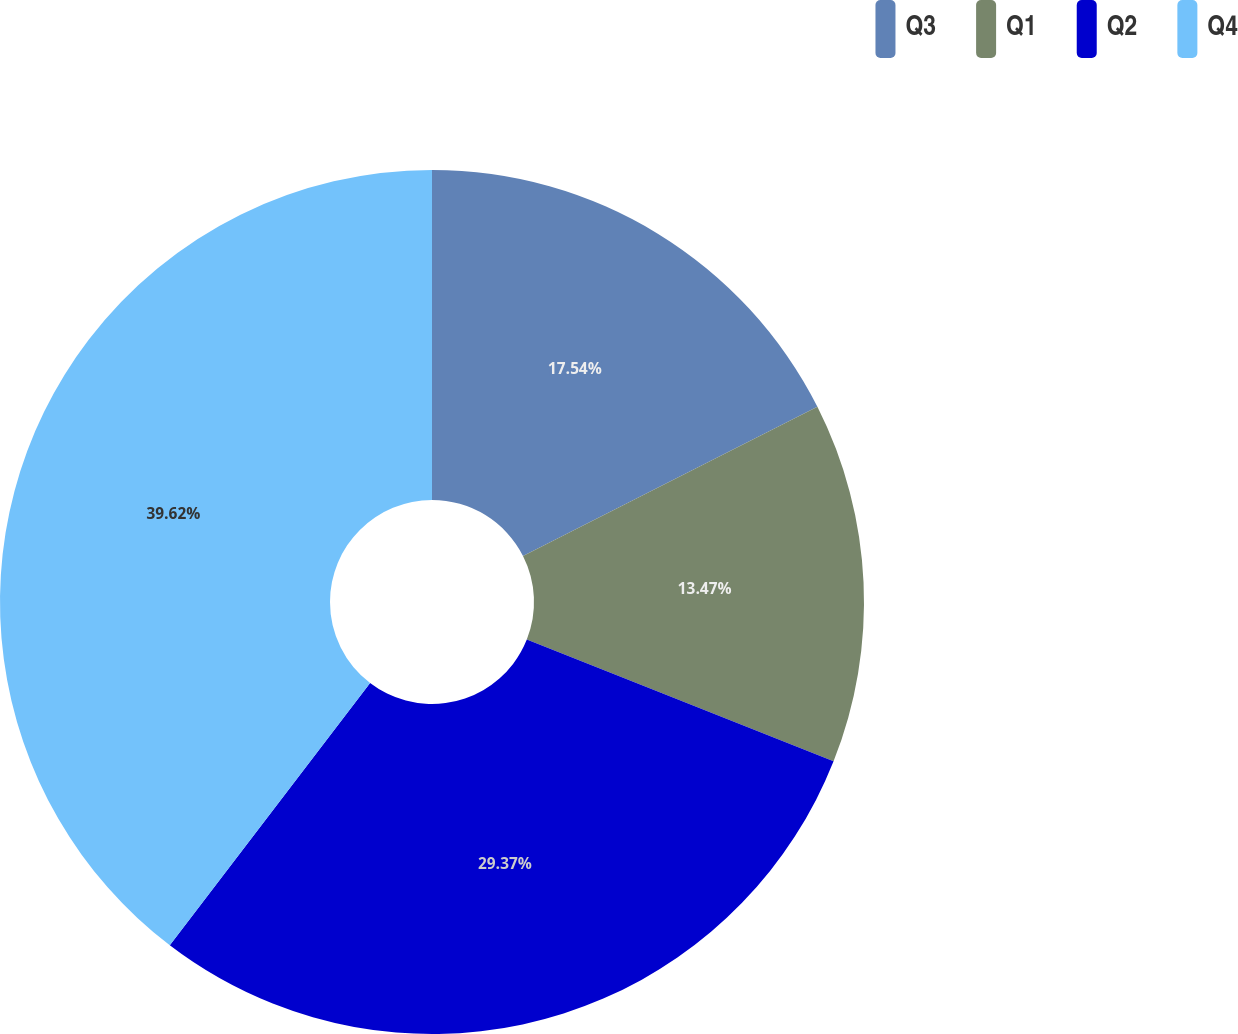<chart> <loc_0><loc_0><loc_500><loc_500><pie_chart><fcel>Q3<fcel>Q1<fcel>Q2<fcel>Q4<nl><fcel>17.54%<fcel>13.47%<fcel>29.37%<fcel>39.62%<nl></chart> 